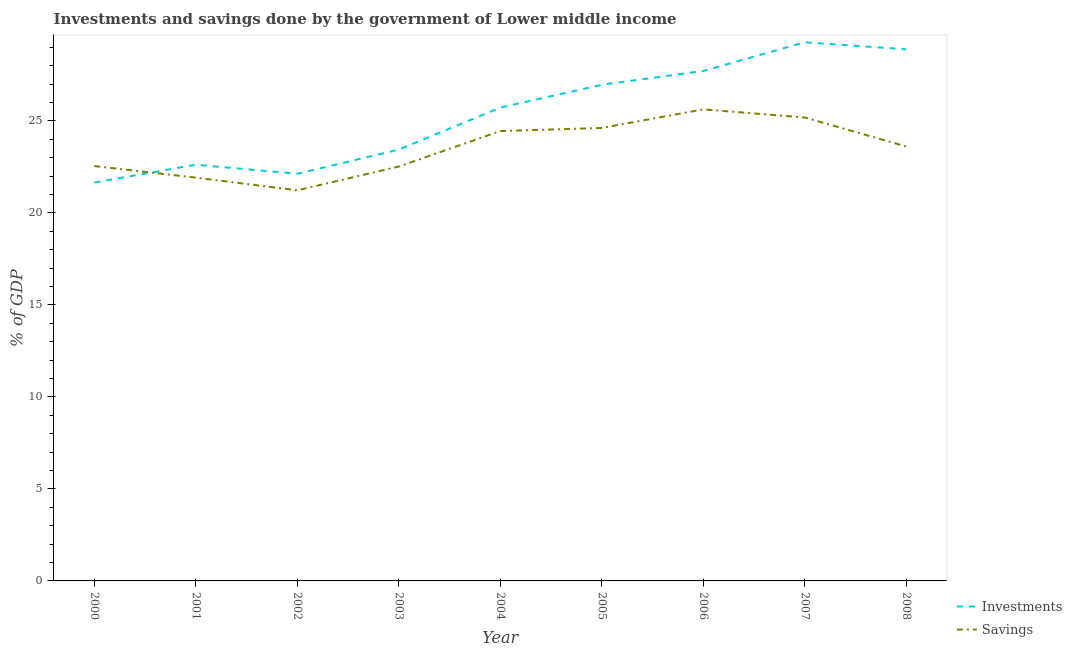Is the number of lines equal to the number of legend labels?
Your response must be concise. Yes. What is the investments of government in 2006?
Your answer should be compact. 27.71. Across all years, what is the maximum investments of government?
Your answer should be compact. 29.27. Across all years, what is the minimum investments of government?
Ensure brevity in your answer.  21.65. In which year was the savings of government maximum?
Your response must be concise. 2006. What is the total investments of government in the graph?
Offer a terse response. 228.38. What is the difference between the investments of government in 2002 and that in 2008?
Ensure brevity in your answer.  -6.76. What is the difference between the investments of government in 2004 and the savings of government in 2001?
Provide a short and direct response. 3.81. What is the average investments of government per year?
Provide a short and direct response. 25.38. In the year 2004, what is the difference between the savings of government and investments of government?
Provide a succinct answer. -1.28. What is the ratio of the investments of government in 2006 to that in 2008?
Your answer should be very brief. 0.96. Is the difference between the investments of government in 2007 and 2008 greater than the difference between the savings of government in 2007 and 2008?
Ensure brevity in your answer.  No. What is the difference between the highest and the second highest savings of government?
Make the answer very short. 0.44. What is the difference between the highest and the lowest investments of government?
Offer a very short reply. 7.62. Is the sum of the savings of government in 2004 and 2008 greater than the maximum investments of government across all years?
Provide a succinct answer. Yes. Is the investments of government strictly greater than the savings of government over the years?
Provide a short and direct response. No. How many lines are there?
Provide a succinct answer. 2. How many years are there in the graph?
Provide a succinct answer. 9. What is the difference between two consecutive major ticks on the Y-axis?
Offer a terse response. 5. Does the graph contain any zero values?
Make the answer very short. No. Does the graph contain grids?
Your answer should be compact. No. How many legend labels are there?
Your response must be concise. 2. How are the legend labels stacked?
Provide a short and direct response. Vertical. What is the title of the graph?
Your answer should be compact. Investments and savings done by the government of Lower middle income. What is the label or title of the X-axis?
Provide a short and direct response. Year. What is the label or title of the Y-axis?
Make the answer very short. % of GDP. What is the % of GDP in Investments in 2000?
Your answer should be compact. 21.65. What is the % of GDP of Savings in 2000?
Provide a succinct answer. 22.54. What is the % of GDP in Investments in 2001?
Your response must be concise. 22.62. What is the % of GDP of Savings in 2001?
Offer a terse response. 21.91. What is the % of GDP in Investments in 2002?
Provide a short and direct response. 22.13. What is the % of GDP of Savings in 2002?
Your response must be concise. 21.23. What is the % of GDP in Investments in 2003?
Make the answer very short. 23.44. What is the % of GDP in Savings in 2003?
Provide a succinct answer. 22.52. What is the % of GDP of Investments in 2004?
Keep it short and to the point. 25.72. What is the % of GDP in Savings in 2004?
Give a very brief answer. 24.45. What is the % of GDP of Investments in 2005?
Your answer should be very brief. 26.96. What is the % of GDP of Savings in 2005?
Offer a very short reply. 24.61. What is the % of GDP of Investments in 2006?
Provide a succinct answer. 27.71. What is the % of GDP of Savings in 2006?
Your response must be concise. 25.62. What is the % of GDP in Investments in 2007?
Ensure brevity in your answer.  29.27. What is the % of GDP in Savings in 2007?
Your answer should be very brief. 25.18. What is the % of GDP of Investments in 2008?
Ensure brevity in your answer.  28.89. What is the % of GDP of Savings in 2008?
Offer a terse response. 23.61. Across all years, what is the maximum % of GDP of Investments?
Your response must be concise. 29.27. Across all years, what is the maximum % of GDP in Savings?
Provide a short and direct response. 25.62. Across all years, what is the minimum % of GDP in Investments?
Keep it short and to the point. 21.65. Across all years, what is the minimum % of GDP of Savings?
Give a very brief answer. 21.23. What is the total % of GDP in Investments in the graph?
Ensure brevity in your answer.  228.38. What is the total % of GDP in Savings in the graph?
Provide a short and direct response. 211.67. What is the difference between the % of GDP in Investments in 2000 and that in 2001?
Give a very brief answer. -0.97. What is the difference between the % of GDP of Savings in 2000 and that in 2001?
Your response must be concise. 0.63. What is the difference between the % of GDP in Investments in 2000 and that in 2002?
Offer a very short reply. -0.48. What is the difference between the % of GDP of Savings in 2000 and that in 2002?
Keep it short and to the point. 1.32. What is the difference between the % of GDP in Investments in 2000 and that in 2003?
Keep it short and to the point. -1.79. What is the difference between the % of GDP in Savings in 2000 and that in 2003?
Your answer should be compact. 0.03. What is the difference between the % of GDP in Investments in 2000 and that in 2004?
Give a very brief answer. -4.07. What is the difference between the % of GDP of Savings in 2000 and that in 2004?
Offer a very short reply. -1.9. What is the difference between the % of GDP of Investments in 2000 and that in 2005?
Make the answer very short. -5.31. What is the difference between the % of GDP of Savings in 2000 and that in 2005?
Provide a short and direct response. -2.07. What is the difference between the % of GDP of Investments in 2000 and that in 2006?
Keep it short and to the point. -6.06. What is the difference between the % of GDP in Savings in 2000 and that in 2006?
Offer a terse response. -3.08. What is the difference between the % of GDP in Investments in 2000 and that in 2007?
Make the answer very short. -7.62. What is the difference between the % of GDP in Savings in 2000 and that in 2007?
Offer a terse response. -2.64. What is the difference between the % of GDP in Investments in 2000 and that in 2008?
Offer a terse response. -7.24. What is the difference between the % of GDP of Savings in 2000 and that in 2008?
Your response must be concise. -1.06. What is the difference between the % of GDP in Investments in 2001 and that in 2002?
Your answer should be compact. 0.49. What is the difference between the % of GDP of Savings in 2001 and that in 2002?
Ensure brevity in your answer.  0.69. What is the difference between the % of GDP of Investments in 2001 and that in 2003?
Provide a short and direct response. -0.82. What is the difference between the % of GDP in Savings in 2001 and that in 2003?
Offer a very short reply. -0.6. What is the difference between the % of GDP in Investments in 2001 and that in 2004?
Keep it short and to the point. -3.1. What is the difference between the % of GDP in Savings in 2001 and that in 2004?
Offer a terse response. -2.53. What is the difference between the % of GDP in Investments in 2001 and that in 2005?
Your answer should be very brief. -4.35. What is the difference between the % of GDP of Savings in 2001 and that in 2005?
Give a very brief answer. -2.7. What is the difference between the % of GDP in Investments in 2001 and that in 2006?
Make the answer very short. -5.1. What is the difference between the % of GDP of Savings in 2001 and that in 2006?
Your answer should be very brief. -3.71. What is the difference between the % of GDP in Investments in 2001 and that in 2007?
Ensure brevity in your answer.  -6.65. What is the difference between the % of GDP of Savings in 2001 and that in 2007?
Offer a very short reply. -3.27. What is the difference between the % of GDP of Investments in 2001 and that in 2008?
Keep it short and to the point. -6.27. What is the difference between the % of GDP in Savings in 2001 and that in 2008?
Your answer should be compact. -1.69. What is the difference between the % of GDP in Investments in 2002 and that in 2003?
Your response must be concise. -1.31. What is the difference between the % of GDP in Savings in 2002 and that in 2003?
Provide a succinct answer. -1.29. What is the difference between the % of GDP of Investments in 2002 and that in 2004?
Your response must be concise. -3.6. What is the difference between the % of GDP in Savings in 2002 and that in 2004?
Keep it short and to the point. -3.22. What is the difference between the % of GDP in Investments in 2002 and that in 2005?
Your answer should be compact. -4.84. What is the difference between the % of GDP in Savings in 2002 and that in 2005?
Offer a terse response. -3.39. What is the difference between the % of GDP of Investments in 2002 and that in 2006?
Offer a very short reply. -5.59. What is the difference between the % of GDP of Savings in 2002 and that in 2006?
Offer a terse response. -4.4. What is the difference between the % of GDP in Investments in 2002 and that in 2007?
Make the answer very short. -7.14. What is the difference between the % of GDP of Savings in 2002 and that in 2007?
Offer a terse response. -3.96. What is the difference between the % of GDP in Investments in 2002 and that in 2008?
Provide a succinct answer. -6.76. What is the difference between the % of GDP in Savings in 2002 and that in 2008?
Provide a short and direct response. -2.38. What is the difference between the % of GDP in Investments in 2003 and that in 2004?
Make the answer very short. -2.28. What is the difference between the % of GDP in Savings in 2003 and that in 2004?
Offer a very short reply. -1.93. What is the difference between the % of GDP in Investments in 2003 and that in 2005?
Ensure brevity in your answer.  -3.52. What is the difference between the % of GDP in Savings in 2003 and that in 2005?
Make the answer very short. -2.1. What is the difference between the % of GDP of Investments in 2003 and that in 2006?
Give a very brief answer. -4.27. What is the difference between the % of GDP in Savings in 2003 and that in 2006?
Provide a succinct answer. -3.11. What is the difference between the % of GDP in Investments in 2003 and that in 2007?
Your answer should be compact. -5.83. What is the difference between the % of GDP of Savings in 2003 and that in 2007?
Make the answer very short. -2.67. What is the difference between the % of GDP of Investments in 2003 and that in 2008?
Offer a very short reply. -5.45. What is the difference between the % of GDP of Savings in 2003 and that in 2008?
Provide a succinct answer. -1.09. What is the difference between the % of GDP of Investments in 2004 and that in 2005?
Give a very brief answer. -1.24. What is the difference between the % of GDP of Savings in 2004 and that in 2005?
Your answer should be compact. -0.17. What is the difference between the % of GDP in Investments in 2004 and that in 2006?
Give a very brief answer. -1.99. What is the difference between the % of GDP in Savings in 2004 and that in 2006?
Ensure brevity in your answer.  -1.18. What is the difference between the % of GDP in Investments in 2004 and that in 2007?
Give a very brief answer. -3.55. What is the difference between the % of GDP in Savings in 2004 and that in 2007?
Give a very brief answer. -0.74. What is the difference between the % of GDP in Investments in 2004 and that in 2008?
Offer a very short reply. -3.17. What is the difference between the % of GDP in Savings in 2004 and that in 2008?
Your answer should be compact. 0.84. What is the difference between the % of GDP in Investments in 2005 and that in 2006?
Offer a terse response. -0.75. What is the difference between the % of GDP in Savings in 2005 and that in 2006?
Give a very brief answer. -1.01. What is the difference between the % of GDP in Investments in 2005 and that in 2007?
Provide a short and direct response. -2.31. What is the difference between the % of GDP of Savings in 2005 and that in 2007?
Provide a succinct answer. -0.57. What is the difference between the % of GDP in Investments in 2005 and that in 2008?
Offer a terse response. -1.93. What is the difference between the % of GDP in Savings in 2005 and that in 2008?
Your answer should be compact. 1.01. What is the difference between the % of GDP of Investments in 2006 and that in 2007?
Give a very brief answer. -1.56. What is the difference between the % of GDP in Savings in 2006 and that in 2007?
Ensure brevity in your answer.  0.44. What is the difference between the % of GDP in Investments in 2006 and that in 2008?
Provide a short and direct response. -1.18. What is the difference between the % of GDP in Savings in 2006 and that in 2008?
Offer a very short reply. 2.02. What is the difference between the % of GDP of Investments in 2007 and that in 2008?
Provide a succinct answer. 0.38. What is the difference between the % of GDP in Savings in 2007 and that in 2008?
Your response must be concise. 1.58. What is the difference between the % of GDP of Investments in 2000 and the % of GDP of Savings in 2001?
Keep it short and to the point. -0.27. What is the difference between the % of GDP of Investments in 2000 and the % of GDP of Savings in 2002?
Provide a short and direct response. 0.42. What is the difference between the % of GDP in Investments in 2000 and the % of GDP in Savings in 2003?
Your answer should be very brief. -0.87. What is the difference between the % of GDP in Investments in 2000 and the % of GDP in Savings in 2004?
Make the answer very short. -2.8. What is the difference between the % of GDP in Investments in 2000 and the % of GDP in Savings in 2005?
Ensure brevity in your answer.  -2.96. What is the difference between the % of GDP of Investments in 2000 and the % of GDP of Savings in 2006?
Offer a terse response. -3.97. What is the difference between the % of GDP in Investments in 2000 and the % of GDP in Savings in 2007?
Your response must be concise. -3.53. What is the difference between the % of GDP of Investments in 2000 and the % of GDP of Savings in 2008?
Ensure brevity in your answer.  -1.96. What is the difference between the % of GDP in Investments in 2001 and the % of GDP in Savings in 2002?
Your response must be concise. 1.39. What is the difference between the % of GDP in Investments in 2001 and the % of GDP in Savings in 2003?
Your answer should be compact. 0.1. What is the difference between the % of GDP in Investments in 2001 and the % of GDP in Savings in 2004?
Your response must be concise. -1.83. What is the difference between the % of GDP of Investments in 2001 and the % of GDP of Savings in 2005?
Offer a very short reply. -2. What is the difference between the % of GDP in Investments in 2001 and the % of GDP in Savings in 2006?
Make the answer very short. -3.01. What is the difference between the % of GDP in Investments in 2001 and the % of GDP in Savings in 2007?
Provide a succinct answer. -2.57. What is the difference between the % of GDP of Investments in 2001 and the % of GDP of Savings in 2008?
Keep it short and to the point. -0.99. What is the difference between the % of GDP of Investments in 2002 and the % of GDP of Savings in 2003?
Ensure brevity in your answer.  -0.39. What is the difference between the % of GDP in Investments in 2002 and the % of GDP in Savings in 2004?
Ensure brevity in your answer.  -2.32. What is the difference between the % of GDP of Investments in 2002 and the % of GDP of Savings in 2005?
Keep it short and to the point. -2.49. What is the difference between the % of GDP in Investments in 2002 and the % of GDP in Savings in 2006?
Your answer should be compact. -3.5. What is the difference between the % of GDP of Investments in 2002 and the % of GDP of Savings in 2007?
Provide a succinct answer. -3.06. What is the difference between the % of GDP of Investments in 2002 and the % of GDP of Savings in 2008?
Provide a succinct answer. -1.48. What is the difference between the % of GDP in Investments in 2003 and the % of GDP in Savings in 2004?
Give a very brief answer. -1.01. What is the difference between the % of GDP of Investments in 2003 and the % of GDP of Savings in 2005?
Keep it short and to the point. -1.17. What is the difference between the % of GDP of Investments in 2003 and the % of GDP of Savings in 2006?
Your answer should be very brief. -2.19. What is the difference between the % of GDP in Investments in 2003 and the % of GDP in Savings in 2007?
Provide a succinct answer. -1.74. What is the difference between the % of GDP in Investments in 2003 and the % of GDP in Savings in 2008?
Provide a succinct answer. -0.17. What is the difference between the % of GDP in Investments in 2004 and the % of GDP in Savings in 2005?
Ensure brevity in your answer.  1.11. What is the difference between the % of GDP of Investments in 2004 and the % of GDP of Savings in 2006?
Make the answer very short. 0.1. What is the difference between the % of GDP of Investments in 2004 and the % of GDP of Savings in 2007?
Your response must be concise. 0.54. What is the difference between the % of GDP of Investments in 2004 and the % of GDP of Savings in 2008?
Provide a succinct answer. 2.11. What is the difference between the % of GDP in Investments in 2005 and the % of GDP in Savings in 2006?
Provide a succinct answer. 1.34. What is the difference between the % of GDP of Investments in 2005 and the % of GDP of Savings in 2007?
Your answer should be very brief. 1.78. What is the difference between the % of GDP in Investments in 2005 and the % of GDP in Savings in 2008?
Provide a succinct answer. 3.36. What is the difference between the % of GDP of Investments in 2006 and the % of GDP of Savings in 2007?
Keep it short and to the point. 2.53. What is the difference between the % of GDP in Investments in 2006 and the % of GDP in Savings in 2008?
Offer a very short reply. 4.11. What is the difference between the % of GDP of Investments in 2007 and the % of GDP of Savings in 2008?
Your answer should be compact. 5.66. What is the average % of GDP of Investments per year?
Keep it short and to the point. 25.38. What is the average % of GDP of Savings per year?
Offer a terse response. 23.52. In the year 2000, what is the difference between the % of GDP of Investments and % of GDP of Savings?
Provide a short and direct response. -0.89. In the year 2001, what is the difference between the % of GDP of Investments and % of GDP of Savings?
Provide a short and direct response. 0.7. In the year 2002, what is the difference between the % of GDP in Investments and % of GDP in Savings?
Provide a short and direct response. 0.9. In the year 2003, what is the difference between the % of GDP of Investments and % of GDP of Savings?
Ensure brevity in your answer.  0.92. In the year 2004, what is the difference between the % of GDP in Investments and % of GDP in Savings?
Your response must be concise. 1.28. In the year 2005, what is the difference between the % of GDP in Investments and % of GDP in Savings?
Provide a succinct answer. 2.35. In the year 2006, what is the difference between the % of GDP in Investments and % of GDP in Savings?
Ensure brevity in your answer.  2.09. In the year 2007, what is the difference between the % of GDP of Investments and % of GDP of Savings?
Your answer should be very brief. 4.09. In the year 2008, what is the difference between the % of GDP of Investments and % of GDP of Savings?
Provide a succinct answer. 5.28. What is the ratio of the % of GDP in Investments in 2000 to that in 2001?
Offer a very short reply. 0.96. What is the ratio of the % of GDP of Savings in 2000 to that in 2001?
Keep it short and to the point. 1.03. What is the ratio of the % of GDP in Investments in 2000 to that in 2002?
Your answer should be compact. 0.98. What is the ratio of the % of GDP of Savings in 2000 to that in 2002?
Offer a very short reply. 1.06. What is the ratio of the % of GDP of Investments in 2000 to that in 2003?
Provide a short and direct response. 0.92. What is the ratio of the % of GDP of Investments in 2000 to that in 2004?
Ensure brevity in your answer.  0.84. What is the ratio of the % of GDP of Savings in 2000 to that in 2004?
Give a very brief answer. 0.92. What is the ratio of the % of GDP in Investments in 2000 to that in 2005?
Your answer should be compact. 0.8. What is the ratio of the % of GDP in Savings in 2000 to that in 2005?
Give a very brief answer. 0.92. What is the ratio of the % of GDP of Investments in 2000 to that in 2006?
Offer a terse response. 0.78. What is the ratio of the % of GDP of Savings in 2000 to that in 2006?
Your response must be concise. 0.88. What is the ratio of the % of GDP of Investments in 2000 to that in 2007?
Your answer should be very brief. 0.74. What is the ratio of the % of GDP in Savings in 2000 to that in 2007?
Keep it short and to the point. 0.9. What is the ratio of the % of GDP of Investments in 2000 to that in 2008?
Your response must be concise. 0.75. What is the ratio of the % of GDP of Savings in 2000 to that in 2008?
Make the answer very short. 0.95. What is the ratio of the % of GDP of Investments in 2001 to that in 2002?
Provide a succinct answer. 1.02. What is the ratio of the % of GDP in Savings in 2001 to that in 2002?
Keep it short and to the point. 1.03. What is the ratio of the % of GDP of Investments in 2001 to that in 2003?
Make the answer very short. 0.96. What is the ratio of the % of GDP of Savings in 2001 to that in 2003?
Keep it short and to the point. 0.97. What is the ratio of the % of GDP of Investments in 2001 to that in 2004?
Make the answer very short. 0.88. What is the ratio of the % of GDP of Savings in 2001 to that in 2004?
Ensure brevity in your answer.  0.9. What is the ratio of the % of GDP in Investments in 2001 to that in 2005?
Offer a very short reply. 0.84. What is the ratio of the % of GDP in Savings in 2001 to that in 2005?
Your answer should be very brief. 0.89. What is the ratio of the % of GDP in Investments in 2001 to that in 2006?
Offer a very short reply. 0.82. What is the ratio of the % of GDP of Savings in 2001 to that in 2006?
Offer a very short reply. 0.86. What is the ratio of the % of GDP of Investments in 2001 to that in 2007?
Ensure brevity in your answer.  0.77. What is the ratio of the % of GDP in Savings in 2001 to that in 2007?
Provide a succinct answer. 0.87. What is the ratio of the % of GDP of Investments in 2001 to that in 2008?
Make the answer very short. 0.78. What is the ratio of the % of GDP in Savings in 2001 to that in 2008?
Your response must be concise. 0.93. What is the ratio of the % of GDP in Investments in 2002 to that in 2003?
Your answer should be very brief. 0.94. What is the ratio of the % of GDP in Savings in 2002 to that in 2003?
Keep it short and to the point. 0.94. What is the ratio of the % of GDP in Investments in 2002 to that in 2004?
Your response must be concise. 0.86. What is the ratio of the % of GDP of Savings in 2002 to that in 2004?
Offer a terse response. 0.87. What is the ratio of the % of GDP in Investments in 2002 to that in 2005?
Make the answer very short. 0.82. What is the ratio of the % of GDP of Savings in 2002 to that in 2005?
Ensure brevity in your answer.  0.86. What is the ratio of the % of GDP in Investments in 2002 to that in 2006?
Your response must be concise. 0.8. What is the ratio of the % of GDP of Savings in 2002 to that in 2006?
Make the answer very short. 0.83. What is the ratio of the % of GDP in Investments in 2002 to that in 2007?
Ensure brevity in your answer.  0.76. What is the ratio of the % of GDP in Savings in 2002 to that in 2007?
Offer a very short reply. 0.84. What is the ratio of the % of GDP of Investments in 2002 to that in 2008?
Your answer should be very brief. 0.77. What is the ratio of the % of GDP in Savings in 2002 to that in 2008?
Ensure brevity in your answer.  0.9. What is the ratio of the % of GDP of Investments in 2003 to that in 2004?
Your answer should be compact. 0.91. What is the ratio of the % of GDP in Savings in 2003 to that in 2004?
Provide a succinct answer. 0.92. What is the ratio of the % of GDP in Investments in 2003 to that in 2005?
Ensure brevity in your answer.  0.87. What is the ratio of the % of GDP of Savings in 2003 to that in 2005?
Your answer should be compact. 0.91. What is the ratio of the % of GDP of Investments in 2003 to that in 2006?
Your answer should be very brief. 0.85. What is the ratio of the % of GDP of Savings in 2003 to that in 2006?
Offer a very short reply. 0.88. What is the ratio of the % of GDP of Investments in 2003 to that in 2007?
Ensure brevity in your answer.  0.8. What is the ratio of the % of GDP in Savings in 2003 to that in 2007?
Offer a terse response. 0.89. What is the ratio of the % of GDP of Investments in 2003 to that in 2008?
Offer a very short reply. 0.81. What is the ratio of the % of GDP of Savings in 2003 to that in 2008?
Your answer should be compact. 0.95. What is the ratio of the % of GDP in Investments in 2004 to that in 2005?
Keep it short and to the point. 0.95. What is the ratio of the % of GDP in Savings in 2004 to that in 2005?
Provide a succinct answer. 0.99. What is the ratio of the % of GDP in Investments in 2004 to that in 2006?
Offer a very short reply. 0.93. What is the ratio of the % of GDP of Savings in 2004 to that in 2006?
Provide a succinct answer. 0.95. What is the ratio of the % of GDP of Investments in 2004 to that in 2007?
Ensure brevity in your answer.  0.88. What is the ratio of the % of GDP of Savings in 2004 to that in 2007?
Keep it short and to the point. 0.97. What is the ratio of the % of GDP of Investments in 2004 to that in 2008?
Provide a short and direct response. 0.89. What is the ratio of the % of GDP in Savings in 2004 to that in 2008?
Give a very brief answer. 1.04. What is the ratio of the % of GDP in Investments in 2005 to that in 2006?
Provide a succinct answer. 0.97. What is the ratio of the % of GDP of Savings in 2005 to that in 2006?
Offer a very short reply. 0.96. What is the ratio of the % of GDP of Investments in 2005 to that in 2007?
Offer a very short reply. 0.92. What is the ratio of the % of GDP in Savings in 2005 to that in 2007?
Make the answer very short. 0.98. What is the ratio of the % of GDP of Investments in 2005 to that in 2008?
Provide a succinct answer. 0.93. What is the ratio of the % of GDP in Savings in 2005 to that in 2008?
Your answer should be very brief. 1.04. What is the ratio of the % of GDP of Investments in 2006 to that in 2007?
Your response must be concise. 0.95. What is the ratio of the % of GDP of Savings in 2006 to that in 2007?
Ensure brevity in your answer.  1.02. What is the ratio of the % of GDP in Investments in 2006 to that in 2008?
Make the answer very short. 0.96. What is the ratio of the % of GDP of Savings in 2006 to that in 2008?
Your answer should be compact. 1.09. What is the ratio of the % of GDP in Investments in 2007 to that in 2008?
Provide a short and direct response. 1.01. What is the ratio of the % of GDP in Savings in 2007 to that in 2008?
Offer a terse response. 1.07. What is the difference between the highest and the second highest % of GDP of Investments?
Your answer should be compact. 0.38. What is the difference between the highest and the second highest % of GDP in Savings?
Your answer should be compact. 0.44. What is the difference between the highest and the lowest % of GDP in Investments?
Keep it short and to the point. 7.62. What is the difference between the highest and the lowest % of GDP in Savings?
Your response must be concise. 4.4. 